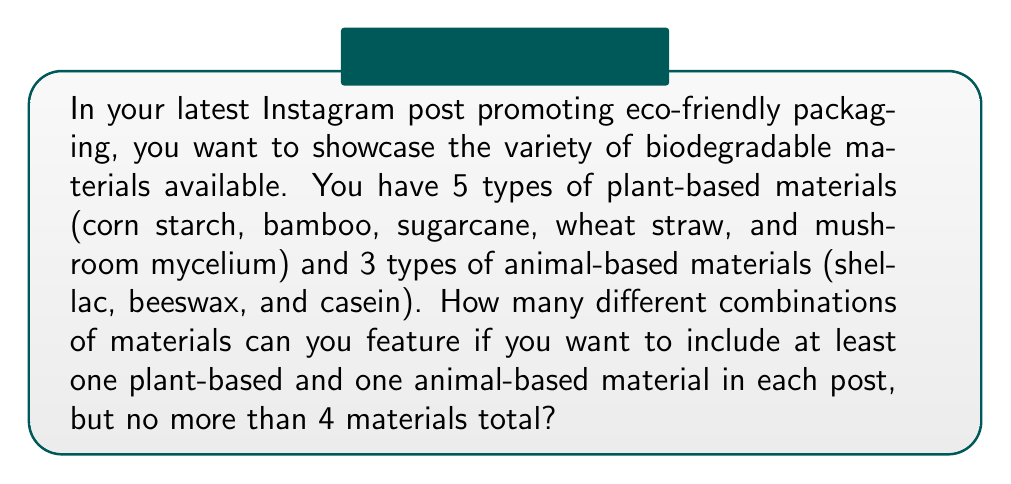Teach me how to tackle this problem. Let's approach this step-by-step:

1) We need to choose at least one from each category, and no more than 4 in total. This means we have three possible scenarios:
   a) 1 plant-based and 1 animal-based
   b) 2 plant-based and 1 animal-based
   c) 1 plant-based and 2 animal-based
   d) 2 plant-based and 2 animal-based
   e) 3 plant-based and 1 animal-based

2) Let's calculate each scenario:

   a) 1 plant-based and 1 animal-based:
      $${5 \choose 1} \times {3 \choose 1} = 5 \times 3 = 15$$

   b) 2 plant-based and 1 animal-based:
      $${5 \choose 2} \times {3 \choose 1} = 10 \times 3 = 30$$

   c) 1 plant-based and 2 animal-based:
      $${5 \choose 1} \times {3 \choose 2} = 5 \times 3 = 15$$

   d) 2 plant-based and 2 animal-based:
      $${5 \choose 2} \times {3 \choose 2} = 10 \times 3 = 30$$

   e) 3 plant-based and 1 animal-based:
      $${5 \choose 3} \times {3 \choose 1} = 10 \times 3 = 30$$

3) The total number of combinations is the sum of all these scenarios:

   $$15 + 30 + 15 + 30 + 30 = 120$$

Therefore, there are 120 different combinations of materials that meet the criteria.
Answer: 120 combinations 